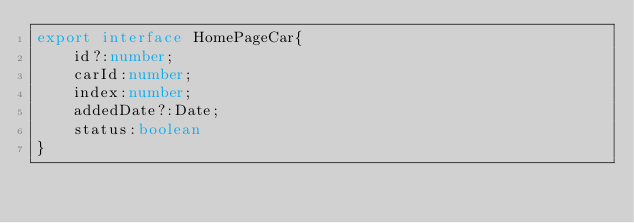<code> <loc_0><loc_0><loc_500><loc_500><_TypeScript_>export interface HomePageCar{
    id?:number;
    carId:number;
    index:number;
    addedDate?:Date;
    status:boolean
}</code> 